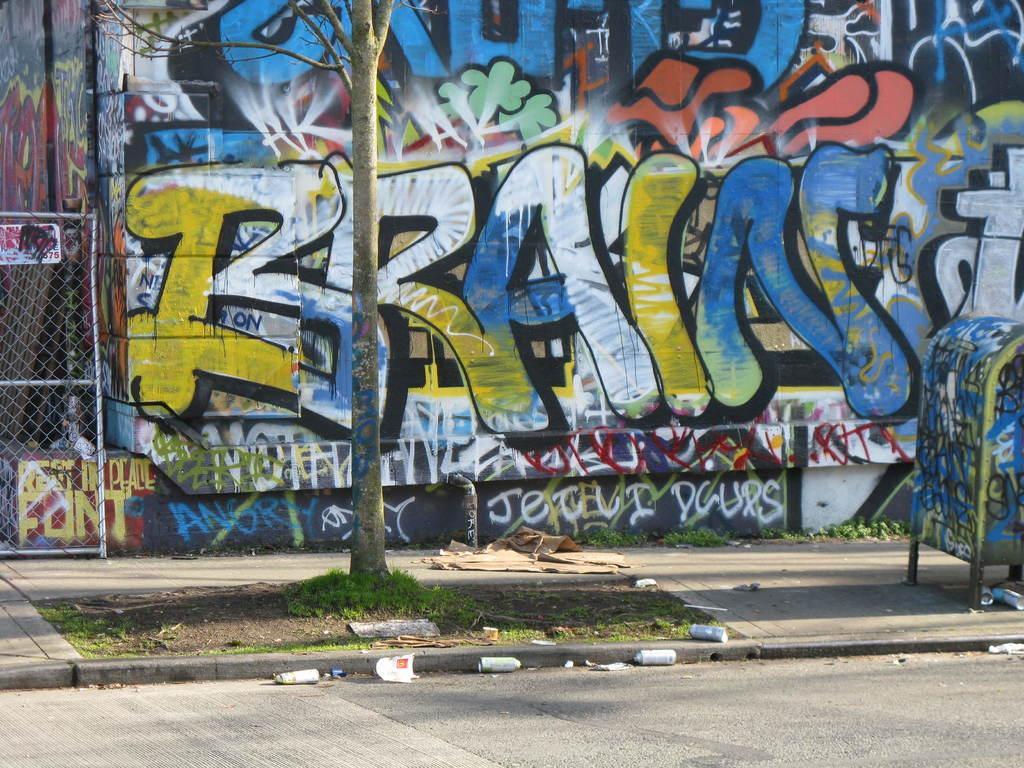Could you give a brief overview of what you see in this image? In the foreground of the picture there are road, tins, grass, tree, dustbin, cloth and other objects. In the center of the picture there is a wall with graffiti. On the left there is fencing. 